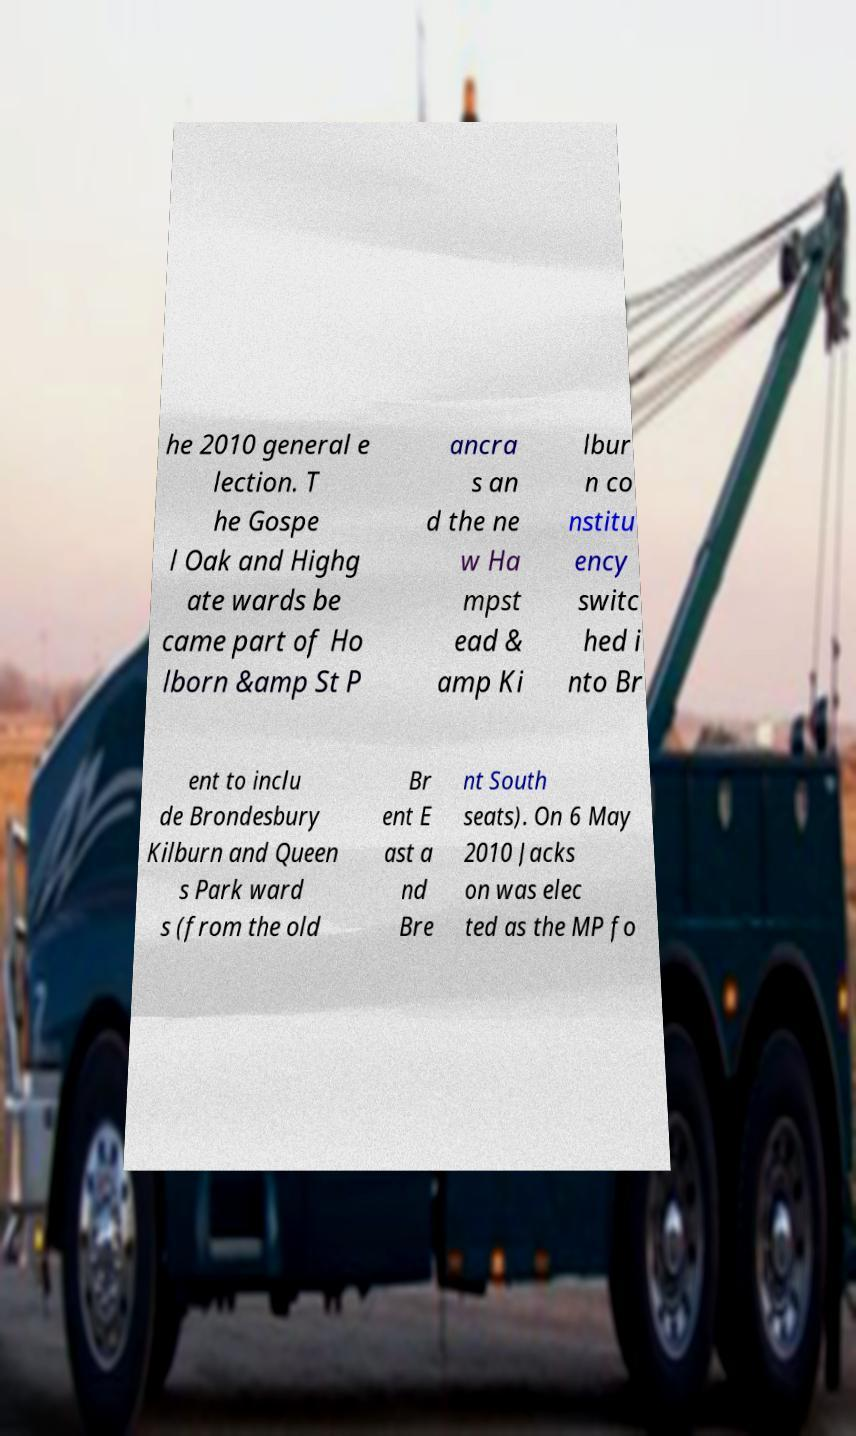For documentation purposes, I need the text within this image transcribed. Could you provide that? he 2010 general e lection. T he Gospe l Oak and Highg ate wards be came part of Ho lborn &amp St P ancra s an d the ne w Ha mpst ead & amp Ki lbur n co nstitu ency switc hed i nto Br ent to inclu de Brondesbury Kilburn and Queen s Park ward s (from the old Br ent E ast a nd Bre nt South seats). On 6 May 2010 Jacks on was elec ted as the MP fo 